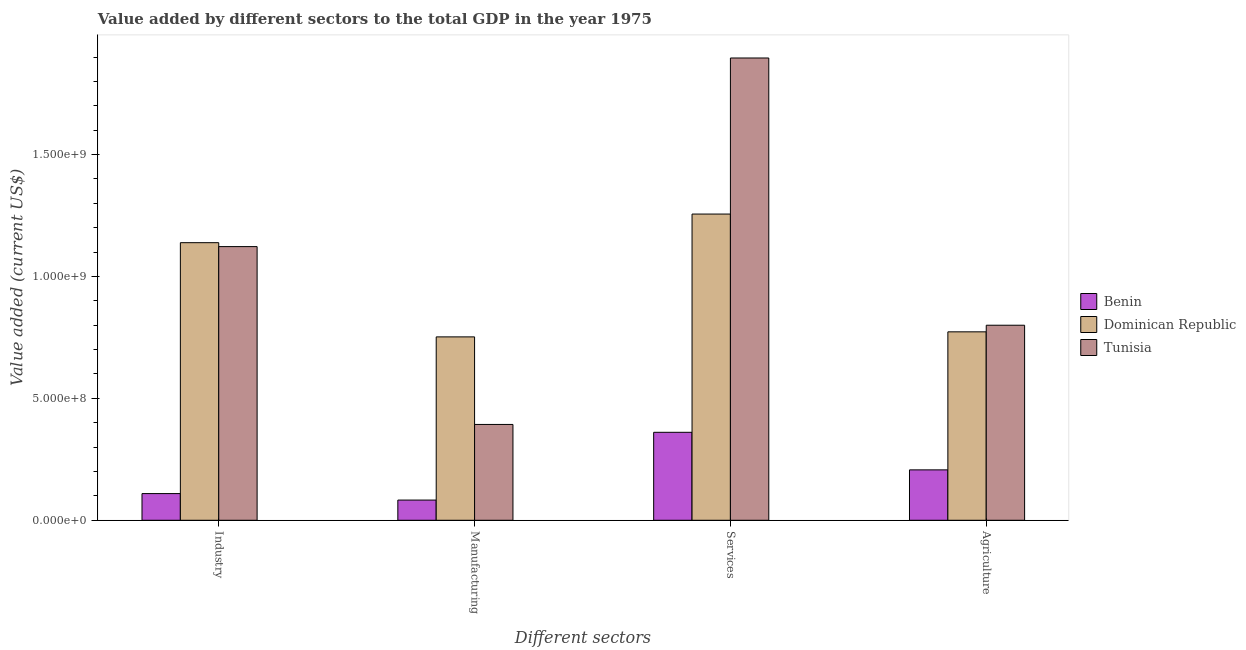Are the number of bars per tick equal to the number of legend labels?
Your answer should be compact. Yes. Are the number of bars on each tick of the X-axis equal?
Provide a succinct answer. Yes. What is the label of the 1st group of bars from the left?
Provide a succinct answer. Industry. What is the value added by industrial sector in Dominican Republic?
Ensure brevity in your answer.  1.14e+09. Across all countries, what is the maximum value added by services sector?
Make the answer very short. 1.90e+09. Across all countries, what is the minimum value added by industrial sector?
Provide a succinct answer. 1.09e+08. In which country was the value added by industrial sector maximum?
Offer a very short reply. Dominican Republic. In which country was the value added by manufacturing sector minimum?
Provide a short and direct response. Benin. What is the total value added by manufacturing sector in the graph?
Provide a succinct answer. 1.23e+09. What is the difference between the value added by services sector in Dominican Republic and that in Benin?
Give a very brief answer. 8.95e+08. What is the difference between the value added by services sector in Dominican Republic and the value added by agricultural sector in Tunisia?
Provide a short and direct response. 4.56e+08. What is the average value added by manufacturing sector per country?
Your answer should be very brief. 4.09e+08. What is the difference between the value added by industrial sector and value added by agricultural sector in Benin?
Offer a terse response. -9.73e+07. What is the ratio of the value added by agricultural sector in Tunisia to that in Benin?
Offer a very short reply. 3.87. What is the difference between the highest and the second highest value added by services sector?
Keep it short and to the point. 6.40e+08. What is the difference between the highest and the lowest value added by manufacturing sector?
Your response must be concise. 6.69e+08. In how many countries, is the value added by services sector greater than the average value added by services sector taken over all countries?
Provide a short and direct response. 2. Is it the case that in every country, the sum of the value added by industrial sector and value added by services sector is greater than the sum of value added by agricultural sector and value added by manufacturing sector?
Offer a terse response. No. What does the 3rd bar from the left in Manufacturing represents?
Keep it short and to the point. Tunisia. What does the 3rd bar from the right in Manufacturing represents?
Your answer should be very brief. Benin. Is it the case that in every country, the sum of the value added by industrial sector and value added by manufacturing sector is greater than the value added by services sector?
Give a very brief answer. No. How many bars are there?
Your response must be concise. 12. Are all the bars in the graph horizontal?
Offer a very short reply. No. How many countries are there in the graph?
Ensure brevity in your answer.  3. Does the graph contain grids?
Keep it short and to the point. No. How are the legend labels stacked?
Give a very brief answer. Vertical. What is the title of the graph?
Offer a terse response. Value added by different sectors to the total GDP in the year 1975. What is the label or title of the X-axis?
Your answer should be compact. Different sectors. What is the label or title of the Y-axis?
Make the answer very short. Value added (current US$). What is the Value added (current US$) in Benin in Industry?
Offer a very short reply. 1.09e+08. What is the Value added (current US$) in Dominican Republic in Industry?
Ensure brevity in your answer.  1.14e+09. What is the Value added (current US$) in Tunisia in Industry?
Provide a short and direct response. 1.12e+09. What is the Value added (current US$) of Benin in Manufacturing?
Give a very brief answer. 8.28e+07. What is the Value added (current US$) in Dominican Republic in Manufacturing?
Your response must be concise. 7.52e+08. What is the Value added (current US$) of Tunisia in Manufacturing?
Your response must be concise. 3.93e+08. What is the Value added (current US$) in Benin in Services?
Your response must be concise. 3.61e+08. What is the Value added (current US$) of Dominican Republic in Services?
Offer a very short reply. 1.26e+09. What is the Value added (current US$) in Tunisia in Services?
Your answer should be very brief. 1.90e+09. What is the Value added (current US$) in Benin in Agriculture?
Provide a succinct answer. 2.07e+08. What is the Value added (current US$) in Dominican Republic in Agriculture?
Give a very brief answer. 7.73e+08. What is the Value added (current US$) in Tunisia in Agriculture?
Make the answer very short. 8.00e+08. Across all Different sectors, what is the maximum Value added (current US$) of Benin?
Give a very brief answer. 3.61e+08. Across all Different sectors, what is the maximum Value added (current US$) in Dominican Republic?
Keep it short and to the point. 1.26e+09. Across all Different sectors, what is the maximum Value added (current US$) of Tunisia?
Provide a short and direct response. 1.90e+09. Across all Different sectors, what is the minimum Value added (current US$) of Benin?
Your answer should be very brief. 8.28e+07. Across all Different sectors, what is the minimum Value added (current US$) of Dominican Republic?
Offer a very short reply. 7.52e+08. Across all Different sectors, what is the minimum Value added (current US$) of Tunisia?
Offer a very short reply. 3.93e+08. What is the total Value added (current US$) in Benin in the graph?
Your answer should be very brief. 7.60e+08. What is the total Value added (current US$) in Dominican Republic in the graph?
Offer a terse response. 3.92e+09. What is the total Value added (current US$) in Tunisia in the graph?
Provide a short and direct response. 4.21e+09. What is the difference between the Value added (current US$) in Benin in Industry and that in Manufacturing?
Make the answer very short. 2.66e+07. What is the difference between the Value added (current US$) in Dominican Republic in Industry and that in Manufacturing?
Provide a succinct answer. 3.86e+08. What is the difference between the Value added (current US$) of Tunisia in Industry and that in Manufacturing?
Make the answer very short. 7.29e+08. What is the difference between the Value added (current US$) of Benin in Industry and that in Services?
Offer a very short reply. -2.51e+08. What is the difference between the Value added (current US$) of Dominican Republic in Industry and that in Services?
Your answer should be very brief. -1.17e+08. What is the difference between the Value added (current US$) of Tunisia in Industry and that in Services?
Your answer should be compact. -7.74e+08. What is the difference between the Value added (current US$) in Benin in Industry and that in Agriculture?
Offer a very short reply. -9.73e+07. What is the difference between the Value added (current US$) in Dominican Republic in Industry and that in Agriculture?
Keep it short and to the point. 3.66e+08. What is the difference between the Value added (current US$) in Tunisia in Industry and that in Agriculture?
Make the answer very short. 3.22e+08. What is the difference between the Value added (current US$) in Benin in Manufacturing and that in Services?
Keep it short and to the point. -2.78e+08. What is the difference between the Value added (current US$) in Dominican Republic in Manufacturing and that in Services?
Keep it short and to the point. -5.04e+08. What is the difference between the Value added (current US$) in Tunisia in Manufacturing and that in Services?
Ensure brevity in your answer.  -1.50e+09. What is the difference between the Value added (current US$) of Benin in Manufacturing and that in Agriculture?
Offer a terse response. -1.24e+08. What is the difference between the Value added (current US$) in Dominican Republic in Manufacturing and that in Agriculture?
Ensure brevity in your answer.  -2.07e+07. What is the difference between the Value added (current US$) of Tunisia in Manufacturing and that in Agriculture?
Your answer should be very brief. -4.07e+08. What is the difference between the Value added (current US$) of Benin in Services and that in Agriculture?
Ensure brevity in your answer.  1.54e+08. What is the difference between the Value added (current US$) in Dominican Republic in Services and that in Agriculture?
Your answer should be compact. 4.83e+08. What is the difference between the Value added (current US$) of Tunisia in Services and that in Agriculture?
Your answer should be very brief. 1.10e+09. What is the difference between the Value added (current US$) of Benin in Industry and the Value added (current US$) of Dominican Republic in Manufacturing?
Ensure brevity in your answer.  -6.43e+08. What is the difference between the Value added (current US$) in Benin in Industry and the Value added (current US$) in Tunisia in Manufacturing?
Make the answer very short. -2.84e+08. What is the difference between the Value added (current US$) of Dominican Republic in Industry and the Value added (current US$) of Tunisia in Manufacturing?
Your answer should be compact. 7.45e+08. What is the difference between the Value added (current US$) in Benin in Industry and the Value added (current US$) in Dominican Republic in Services?
Offer a terse response. -1.15e+09. What is the difference between the Value added (current US$) in Benin in Industry and the Value added (current US$) in Tunisia in Services?
Your answer should be very brief. -1.79e+09. What is the difference between the Value added (current US$) in Dominican Republic in Industry and the Value added (current US$) in Tunisia in Services?
Keep it short and to the point. -7.57e+08. What is the difference between the Value added (current US$) of Benin in Industry and the Value added (current US$) of Dominican Republic in Agriculture?
Your answer should be very brief. -6.63e+08. What is the difference between the Value added (current US$) of Benin in Industry and the Value added (current US$) of Tunisia in Agriculture?
Your answer should be very brief. -6.91e+08. What is the difference between the Value added (current US$) in Dominican Republic in Industry and the Value added (current US$) in Tunisia in Agriculture?
Your answer should be very brief. 3.39e+08. What is the difference between the Value added (current US$) in Benin in Manufacturing and the Value added (current US$) in Dominican Republic in Services?
Your answer should be very brief. -1.17e+09. What is the difference between the Value added (current US$) in Benin in Manufacturing and the Value added (current US$) in Tunisia in Services?
Your response must be concise. -1.81e+09. What is the difference between the Value added (current US$) of Dominican Republic in Manufacturing and the Value added (current US$) of Tunisia in Services?
Keep it short and to the point. -1.14e+09. What is the difference between the Value added (current US$) in Benin in Manufacturing and the Value added (current US$) in Dominican Republic in Agriculture?
Give a very brief answer. -6.90e+08. What is the difference between the Value added (current US$) of Benin in Manufacturing and the Value added (current US$) of Tunisia in Agriculture?
Offer a terse response. -7.17e+08. What is the difference between the Value added (current US$) of Dominican Republic in Manufacturing and the Value added (current US$) of Tunisia in Agriculture?
Ensure brevity in your answer.  -4.79e+07. What is the difference between the Value added (current US$) in Benin in Services and the Value added (current US$) in Dominican Republic in Agriculture?
Make the answer very short. -4.12e+08. What is the difference between the Value added (current US$) of Benin in Services and the Value added (current US$) of Tunisia in Agriculture?
Ensure brevity in your answer.  -4.39e+08. What is the difference between the Value added (current US$) of Dominican Republic in Services and the Value added (current US$) of Tunisia in Agriculture?
Keep it short and to the point. 4.56e+08. What is the average Value added (current US$) in Benin per Different sectors?
Give a very brief answer. 1.90e+08. What is the average Value added (current US$) of Dominican Republic per Different sectors?
Provide a succinct answer. 9.80e+08. What is the average Value added (current US$) in Tunisia per Different sectors?
Your answer should be compact. 1.05e+09. What is the difference between the Value added (current US$) of Benin and Value added (current US$) of Dominican Republic in Industry?
Give a very brief answer. -1.03e+09. What is the difference between the Value added (current US$) of Benin and Value added (current US$) of Tunisia in Industry?
Keep it short and to the point. -1.01e+09. What is the difference between the Value added (current US$) in Dominican Republic and Value added (current US$) in Tunisia in Industry?
Provide a short and direct response. 1.61e+07. What is the difference between the Value added (current US$) in Benin and Value added (current US$) in Dominican Republic in Manufacturing?
Make the answer very short. -6.69e+08. What is the difference between the Value added (current US$) in Benin and Value added (current US$) in Tunisia in Manufacturing?
Your answer should be compact. -3.10e+08. What is the difference between the Value added (current US$) in Dominican Republic and Value added (current US$) in Tunisia in Manufacturing?
Provide a short and direct response. 3.59e+08. What is the difference between the Value added (current US$) in Benin and Value added (current US$) in Dominican Republic in Services?
Keep it short and to the point. -8.95e+08. What is the difference between the Value added (current US$) of Benin and Value added (current US$) of Tunisia in Services?
Your answer should be very brief. -1.54e+09. What is the difference between the Value added (current US$) of Dominican Republic and Value added (current US$) of Tunisia in Services?
Provide a succinct answer. -6.40e+08. What is the difference between the Value added (current US$) of Benin and Value added (current US$) of Dominican Republic in Agriculture?
Give a very brief answer. -5.66e+08. What is the difference between the Value added (current US$) in Benin and Value added (current US$) in Tunisia in Agriculture?
Your response must be concise. -5.93e+08. What is the difference between the Value added (current US$) of Dominican Republic and Value added (current US$) of Tunisia in Agriculture?
Your response must be concise. -2.72e+07. What is the ratio of the Value added (current US$) in Benin in Industry to that in Manufacturing?
Your answer should be very brief. 1.32. What is the ratio of the Value added (current US$) of Dominican Republic in Industry to that in Manufacturing?
Provide a short and direct response. 1.51. What is the ratio of the Value added (current US$) of Tunisia in Industry to that in Manufacturing?
Your response must be concise. 2.86. What is the ratio of the Value added (current US$) in Benin in Industry to that in Services?
Provide a succinct answer. 0.3. What is the ratio of the Value added (current US$) of Dominican Republic in Industry to that in Services?
Ensure brevity in your answer.  0.91. What is the ratio of the Value added (current US$) in Tunisia in Industry to that in Services?
Offer a very short reply. 0.59. What is the ratio of the Value added (current US$) of Benin in Industry to that in Agriculture?
Provide a succinct answer. 0.53. What is the ratio of the Value added (current US$) in Dominican Republic in Industry to that in Agriculture?
Make the answer very short. 1.47. What is the ratio of the Value added (current US$) in Tunisia in Industry to that in Agriculture?
Your answer should be very brief. 1.4. What is the ratio of the Value added (current US$) of Benin in Manufacturing to that in Services?
Provide a succinct answer. 0.23. What is the ratio of the Value added (current US$) of Dominican Republic in Manufacturing to that in Services?
Your response must be concise. 0.6. What is the ratio of the Value added (current US$) in Tunisia in Manufacturing to that in Services?
Your answer should be compact. 0.21. What is the ratio of the Value added (current US$) of Benin in Manufacturing to that in Agriculture?
Offer a very short reply. 0.4. What is the ratio of the Value added (current US$) in Dominican Republic in Manufacturing to that in Agriculture?
Your answer should be compact. 0.97. What is the ratio of the Value added (current US$) of Tunisia in Manufacturing to that in Agriculture?
Ensure brevity in your answer.  0.49. What is the ratio of the Value added (current US$) of Benin in Services to that in Agriculture?
Keep it short and to the point. 1.75. What is the ratio of the Value added (current US$) of Dominican Republic in Services to that in Agriculture?
Give a very brief answer. 1.63. What is the ratio of the Value added (current US$) of Tunisia in Services to that in Agriculture?
Ensure brevity in your answer.  2.37. What is the difference between the highest and the second highest Value added (current US$) in Benin?
Keep it short and to the point. 1.54e+08. What is the difference between the highest and the second highest Value added (current US$) in Dominican Republic?
Offer a terse response. 1.17e+08. What is the difference between the highest and the second highest Value added (current US$) in Tunisia?
Provide a short and direct response. 7.74e+08. What is the difference between the highest and the lowest Value added (current US$) of Benin?
Give a very brief answer. 2.78e+08. What is the difference between the highest and the lowest Value added (current US$) of Dominican Republic?
Your answer should be compact. 5.04e+08. What is the difference between the highest and the lowest Value added (current US$) of Tunisia?
Provide a short and direct response. 1.50e+09. 